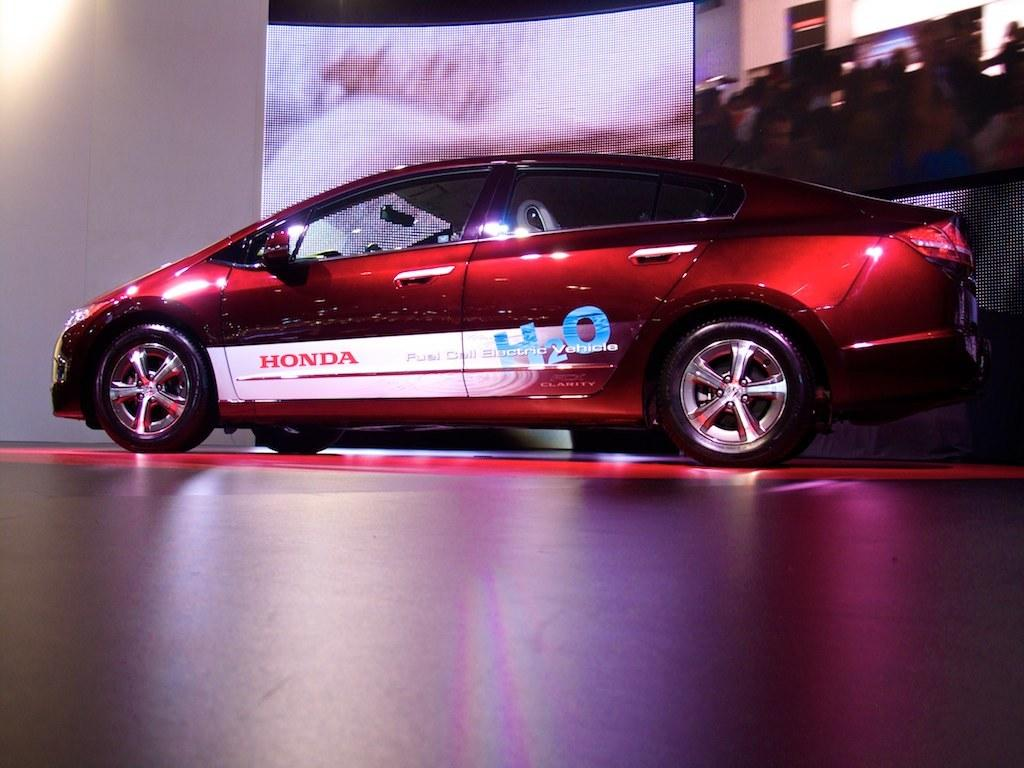What type of vehicle is in the picture? There is a red car in the picture. What can be seen in the background of the picture? There are screens in the background of the picture. What color is the crayon on the toe of the person in the picture? There is no person or crayon present in the picture; it only features a red car and screens in the background. 